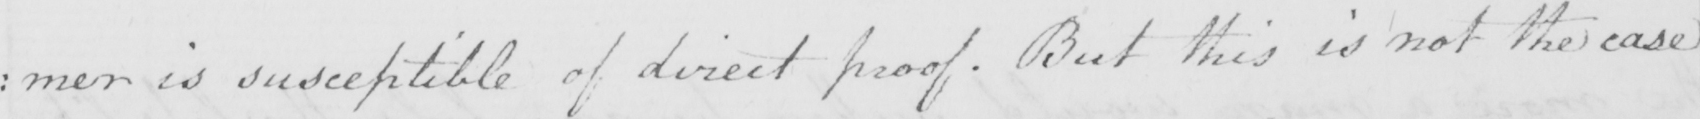What does this handwritten line say? : mer is susceptible of direct proof . But this is not the case 